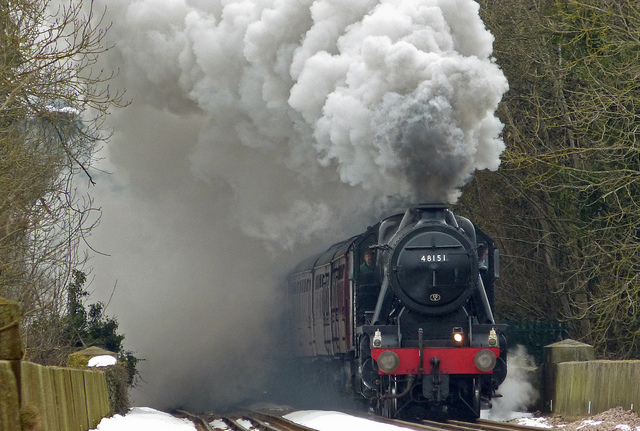<image>Could Sabin suplex this train? I am unsure if Sabin could suplex this train. Could Sabin suplex this train? I don't know if Sabin could suplex this train. It is uncertain. 